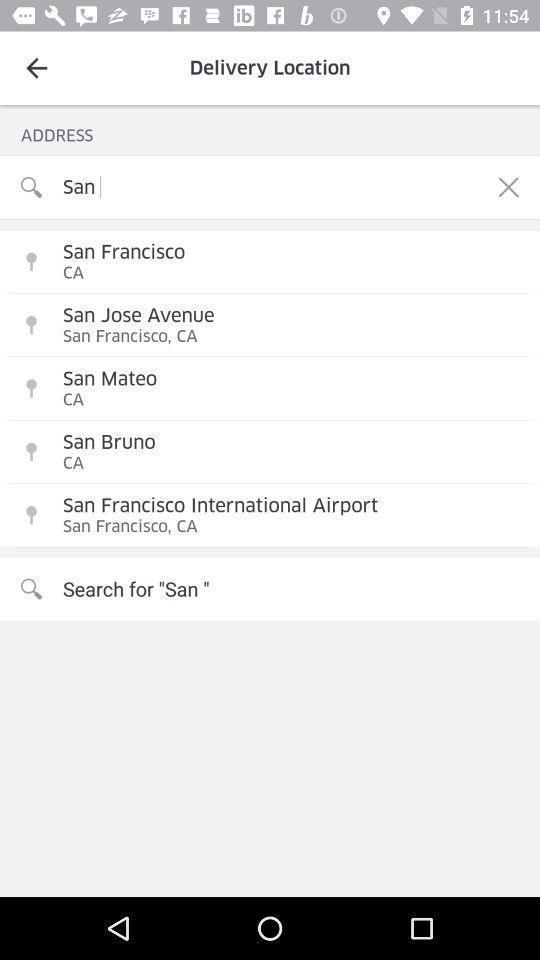Explain what's happening in this screen capture. Screen showing search bar. 